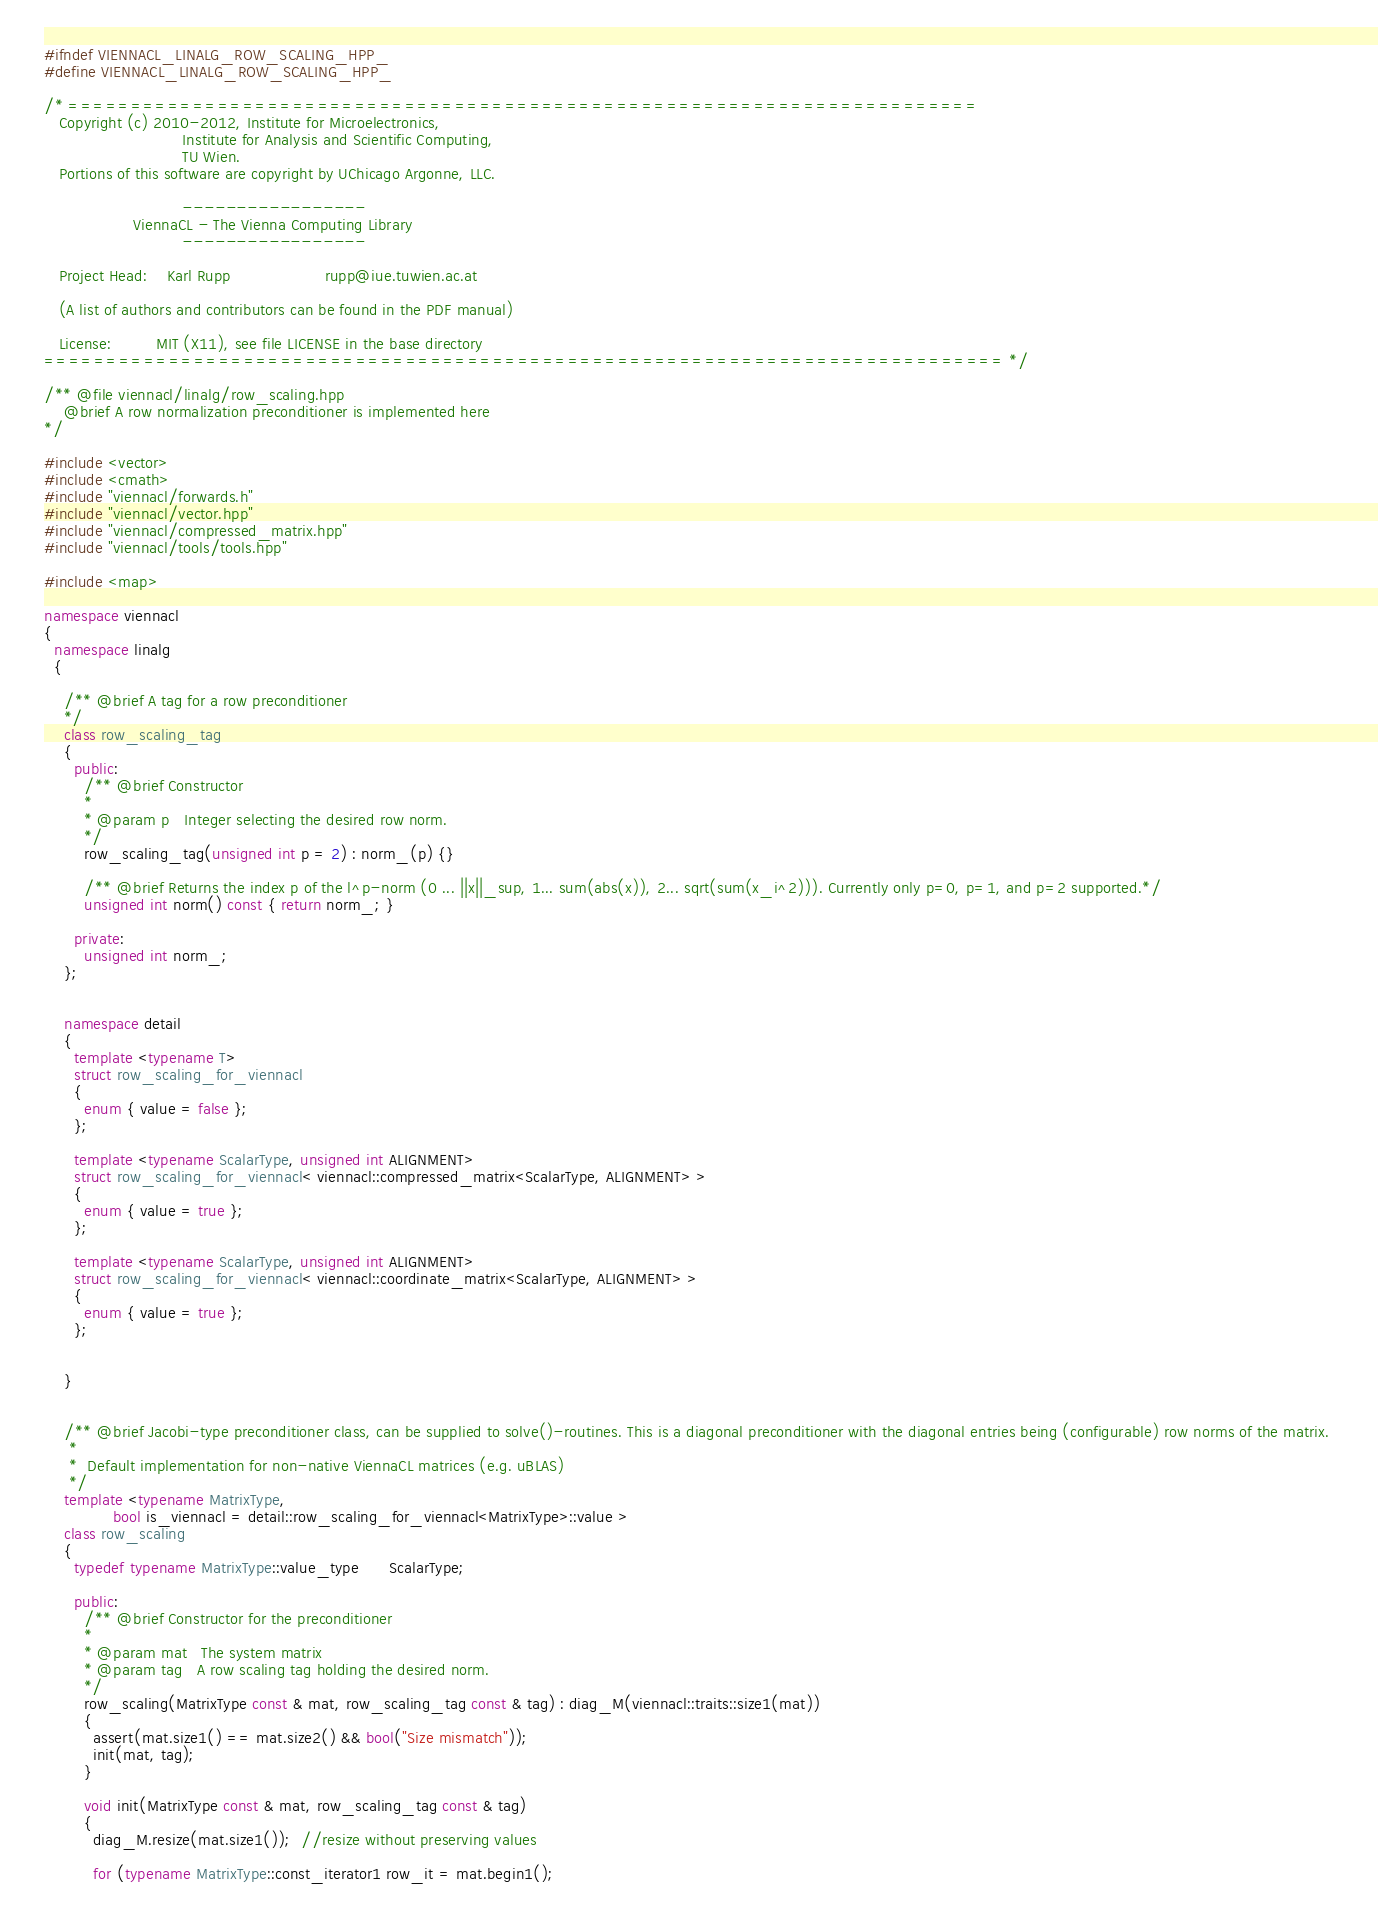Convert code to text. <code><loc_0><loc_0><loc_500><loc_500><_C++_>#ifndef VIENNACL_LINALG_ROW_SCALING_HPP_
#define VIENNACL_LINALG_ROW_SCALING_HPP_

/* =========================================================================
   Copyright (c) 2010-2012, Institute for Microelectronics,
                            Institute for Analysis and Scientific Computing,
                            TU Wien.
   Portions of this software are copyright by UChicago Argonne, LLC.

                            -----------------
                  ViennaCL - The Vienna Computing Library
                            -----------------

   Project Head:    Karl Rupp                   rupp@iue.tuwien.ac.at
               
   (A list of authors and contributors can be found in the PDF manual)

   License:         MIT (X11), see file LICENSE in the base directory
============================================================================= */

/** @file viennacl/linalg/row_scaling.hpp
    @brief A row normalization preconditioner is implemented here
*/

#include <vector>
#include <cmath>
#include "viennacl/forwards.h"
#include "viennacl/vector.hpp"
#include "viennacl/compressed_matrix.hpp"
#include "viennacl/tools/tools.hpp"

#include <map>

namespace viennacl
{
  namespace linalg
  {
    
    /** @brief A tag for a row preconditioner
    */
    class row_scaling_tag
    {
      public:
        /** @brief Constructor
        *
        * @param p   Integer selecting the desired row norm.
        */
        row_scaling_tag(unsigned int p = 2) : norm_(p) {}
        
        /** @brief Returns the index p of the l^p-norm (0 ... ||x||_sup, 1... sum(abs(x)), 2... sqrt(sum(x_i^2))). Currently only p=0, p=1, and p=2 supported.*/
        unsigned int norm() const { return norm_; }
        
      private:
        unsigned int norm_;
    };

    
    namespace detail
    {
      template <typename T>
      struct row_scaling_for_viennacl
      {
        enum { value = false };
      };
      
      template <typename ScalarType, unsigned int ALIGNMENT>
      struct row_scaling_for_viennacl< viennacl::compressed_matrix<ScalarType, ALIGNMENT> >
      {
        enum { value = true };
      };
      
      template <typename ScalarType, unsigned int ALIGNMENT>
      struct row_scaling_for_viennacl< viennacl::coordinate_matrix<ScalarType, ALIGNMENT> >
      {
        enum { value = true };
      };
      
      
    }
    

    /** @brief Jacobi-type preconditioner class, can be supplied to solve()-routines. This is a diagonal preconditioner with the diagonal entries being (configurable) row norms of the matrix. 
     *
     *  Default implementation for non-native ViennaCL matrices (e.g. uBLAS)
     */
    template <typename MatrixType,
              bool is_viennacl = detail::row_scaling_for_viennacl<MatrixType>::value >
    class row_scaling
    {
      typedef typename MatrixType::value_type      ScalarType;
      
      public:
        /** @brief Constructor for the preconditioner
        *
        * @param mat   The system matrix
        * @param tag   A row scaling tag holding the desired norm.
        */
        row_scaling(MatrixType const & mat, row_scaling_tag const & tag) : diag_M(viennacl::traits::size1(mat))
        {
          assert(mat.size1() == mat.size2() && bool("Size mismatch"));
          init(mat, tag);
        }
        
        void init(MatrixType const & mat, row_scaling_tag const & tag)
        {
          diag_M.resize(mat.size1());  //resize without preserving values
          
          for (typename MatrixType::const_iterator1 row_it = mat.begin1();</code> 